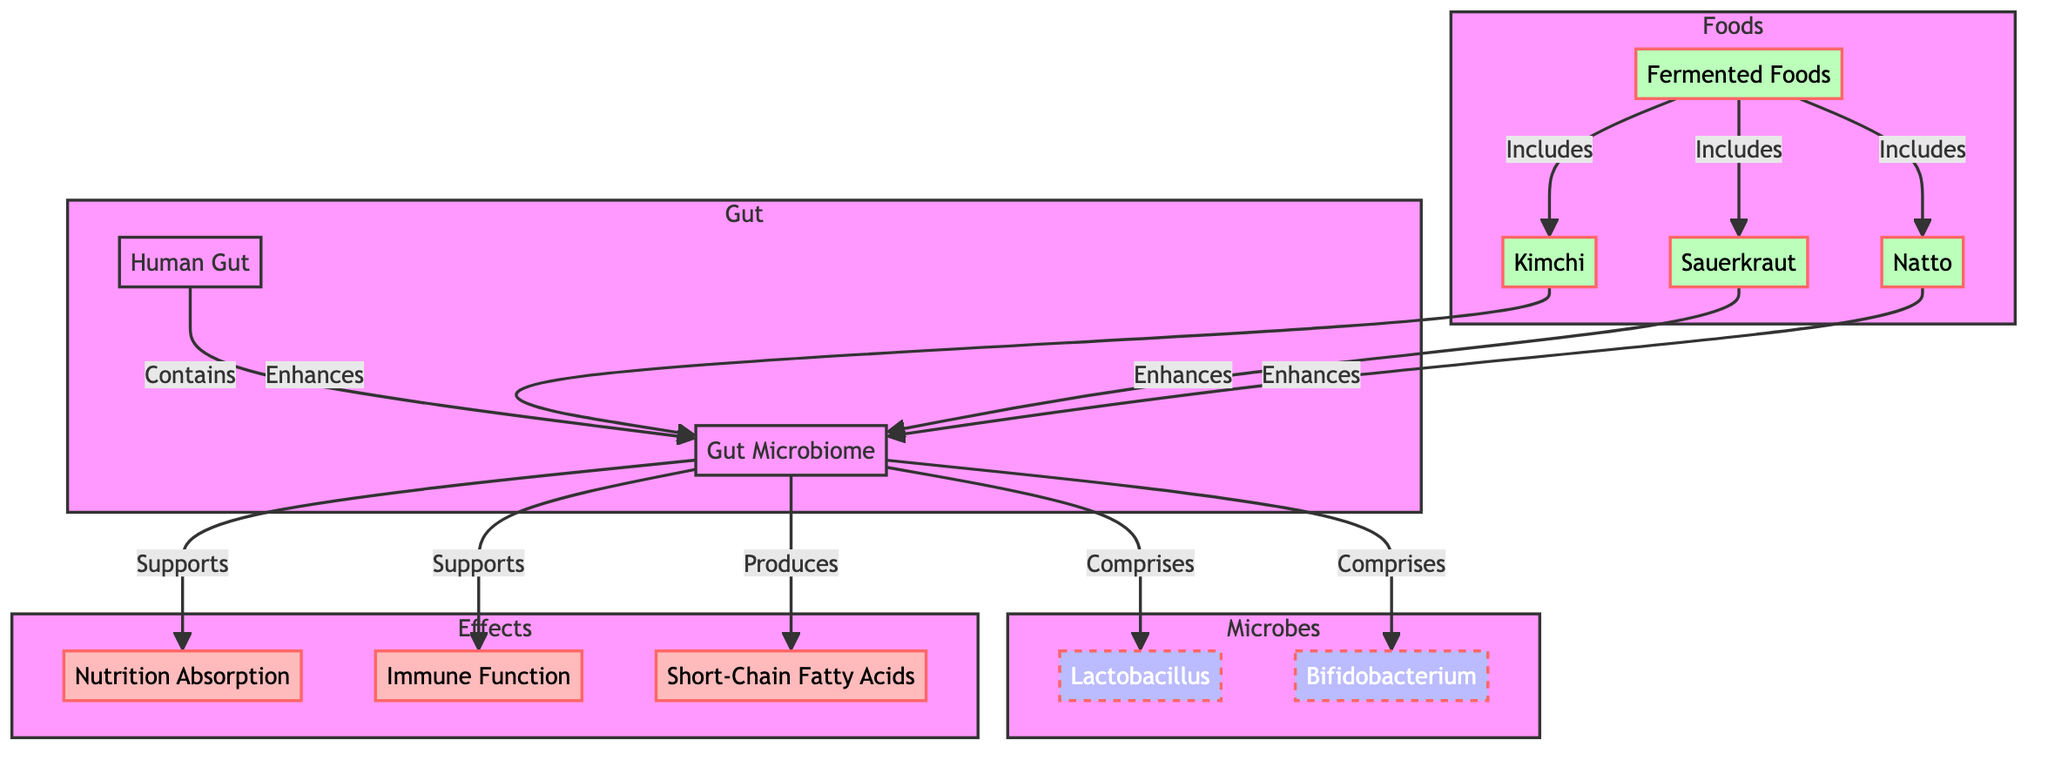What is the primary component of the Human Gut? The diagram shows that the Human Gut contains the Gut Microbiome as a primary component. Therefore, the answer can be directly inferred from the edge connecting the two nodes.
Answer: Gut Microbiome How many types of fermented foods are represented in the diagram? The diagram lists three types of fermented foods: Kimchi, Sauerkraut, and Natto, which can be counted directly from the nodes under the Foods subgraph.
Answer: 3 Which bacteria are part of the Gut Microbiome? The Gut Microbiome comprises two types of bacteria: Lactobacillus and Bifidobacterium, as indicated by the edges connecting the Gut Microbiome node to these specific microbe nodes.
Answer: Lactobacillus, Bifidobacterium What is the relationship between Fermented Foods and Gut Microbiome? The edges show that each type of Fermented Food enhances the Gut Microbiome. Specifically, Kimchi, Sauerkraut, and Natto all have directed edges towards the Gut Microbiome with the label "Enhances", indicating a beneficial effect.
Answer: Enhances How do Gut Microbes affect Nutrition Absorption? The diagram illustrates that the Gut Microbiome supports Nutrition Absorption, shown by the directed edge from the Gut Microbiome to the Nutrition Absorption node. This signifies that the presence of gut microbes is beneficial for nutrient absorption.
Answer: Supports Which component produces Short-Chain Fatty Acids? Analyzing the edges, it's evident that the Gut Microbiome produces Short-Chain Fatty Acids, indicated by the edge leading from the Gut Microbiome node to the Short-Chain Fatty Acids node.
Answer: Gut Microbiome From the diagram, how many edges connect Fermented Foods to the Gut Microbiome? There are three edges connecting Fermented Foods (Kimchi, Sauerkraut, and Natto) to the Gut Microbiome, as indicated by the separate lines from each food to the Gut Microbiome.
Answer: 3 What effect do Gut Microbes have on Immune Function? The diagram shows that the Gut Microbiome supports Immune Function, as indicated by the edge leading from the Gut Microbiome node to the Immune Function node. This suggests a supportive role of gut microbes in immune health.
Answer: Supports Which type of bacteria enhances the Gut Microbiome along with fermented foods? The diagram indicates that both Lactobacillus and Bifidobacterium are bacteria that comprise the Gut Microbiome, implying their roles in enhancing the microbiome alongside fermented foods like Kimchi, Sauerkraut, and Natto.
Answer: Lactobacillus, Bifidobacterium 